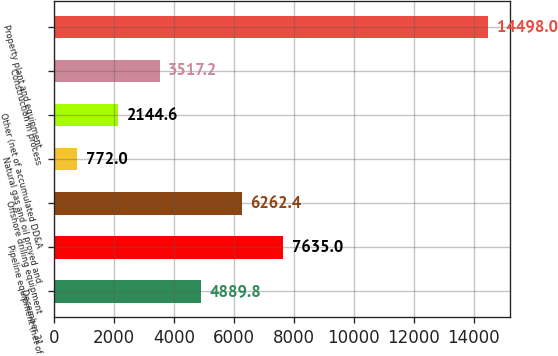<chart> <loc_0><loc_0><loc_500><loc_500><bar_chart><fcel>December 31<fcel>Pipeline equipment (net of<fcel>Offshore drilling equipment<fcel>Natural gas and oil proved and<fcel>Other (net of accumulated DD&A<fcel>Construction in process<fcel>Property plant and equipment<nl><fcel>4889.8<fcel>7635<fcel>6262.4<fcel>772<fcel>2144.6<fcel>3517.2<fcel>14498<nl></chart> 